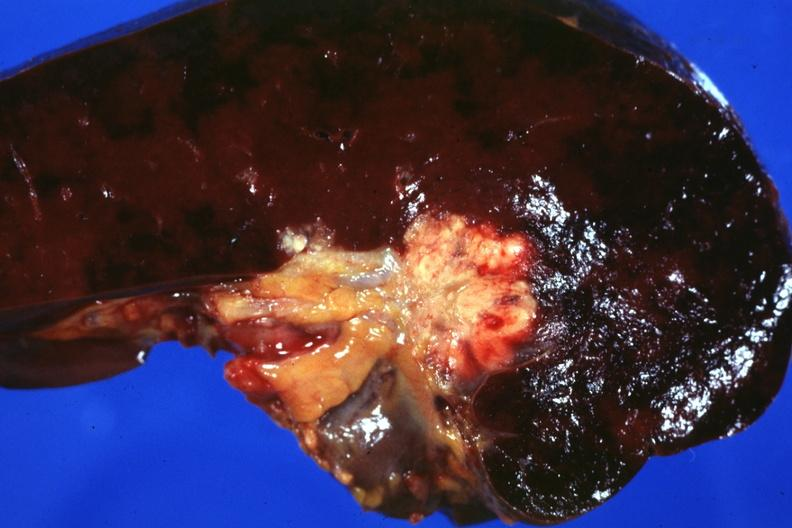does hemorrhage newborn make one wonder whether node metastases spread into the spleen in this case?
Answer the question using a single word or phrase. No 